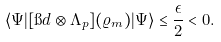Convert formula to latex. <formula><loc_0><loc_0><loc_500><loc_500>\langle \Psi | [ \i d \otimes \Lambda _ { p } ] ( \varrho _ { m } ) | \Psi \rangle \leq \frac { \epsilon } { 2 } < 0 .</formula> 